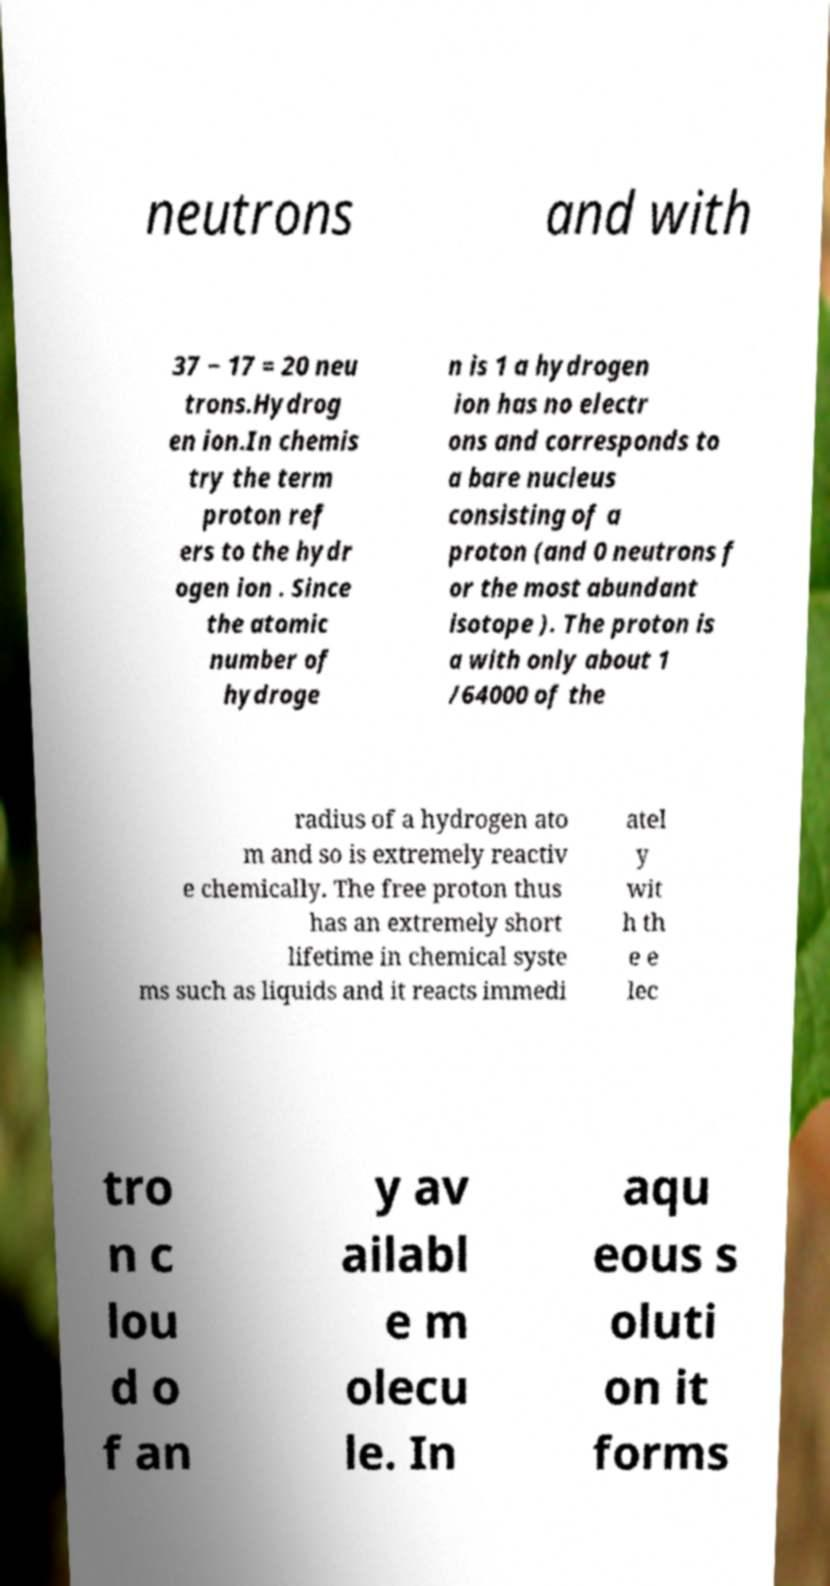Could you assist in decoding the text presented in this image and type it out clearly? neutrons and with 37 − 17 = 20 neu trons.Hydrog en ion.In chemis try the term proton ref ers to the hydr ogen ion . Since the atomic number of hydroge n is 1 a hydrogen ion has no electr ons and corresponds to a bare nucleus consisting of a proton (and 0 neutrons f or the most abundant isotope ). The proton is a with only about 1 /64000 of the radius of a hydrogen ato m and so is extremely reactiv e chemically. The free proton thus has an extremely short lifetime in chemical syste ms such as liquids and it reacts immedi atel y wit h th e e lec tro n c lou d o f an y av ailabl e m olecu le. In aqu eous s oluti on it forms 